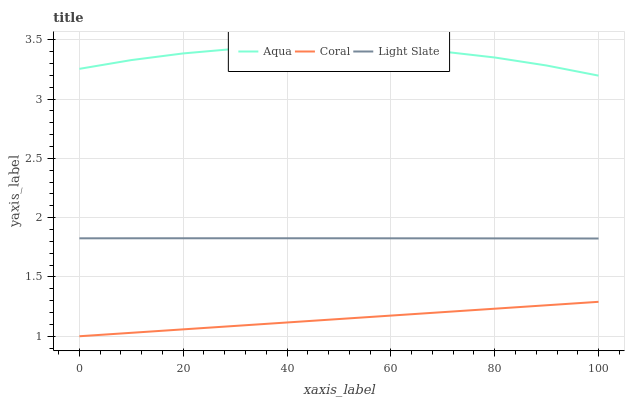Does Coral have the minimum area under the curve?
Answer yes or no. Yes. Does Aqua have the maximum area under the curve?
Answer yes or no. Yes. Does Aqua have the minimum area under the curve?
Answer yes or no. No. Does Coral have the maximum area under the curve?
Answer yes or no. No. Is Coral the smoothest?
Answer yes or no. Yes. Is Aqua the roughest?
Answer yes or no. Yes. Is Aqua the smoothest?
Answer yes or no. No. Is Coral the roughest?
Answer yes or no. No. Does Coral have the lowest value?
Answer yes or no. Yes. Does Aqua have the lowest value?
Answer yes or no. No. Does Aqua have the highest value?
Answer yes or no. Yes. Does Coral have the highest value?
Answer yes or no. No. Is Coral less than Light Slate?
Answer yes or no. Yes. Is Aqua greater than Coral?
Answer yes or no. Yes. Does Coral intersect Light Slate?
Answer yes or no. No. 